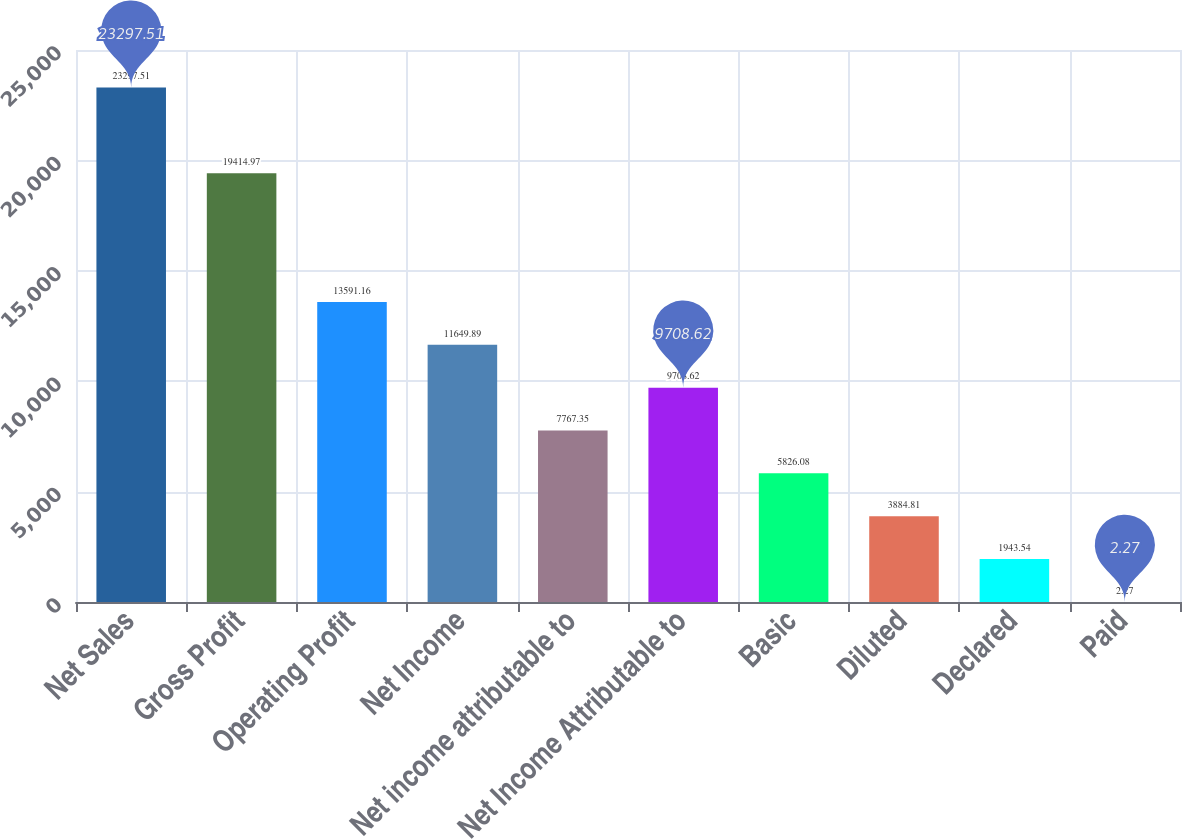Convert chart to OTSL. <chart><loc_0><loc_0><loc_500><loc_500><bar_chart><fcel>Net Sales<fcel>Gross Profit<fcel>Operating Profit<fcel>Net Income<fcel>Net income attributable to<fcel>Net Income Attributable to<fcel>Basic<fcel>Diluted<fcel>Declared<fcel>Paid<nl><fcel>23297.5<fcel>19415<fcel>13591.2<fcel>11649.9<fcel>7767.35<fcel>9708.62<fcel>5826.08<fcel>3884.81<fcel>1943.54<fcel>2.27<nl></chart> 